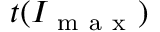Convert formula to latex. <formula><loc_0><loc_0><loc_500><loc_500>t ( I _ { m a x } )</formula> 